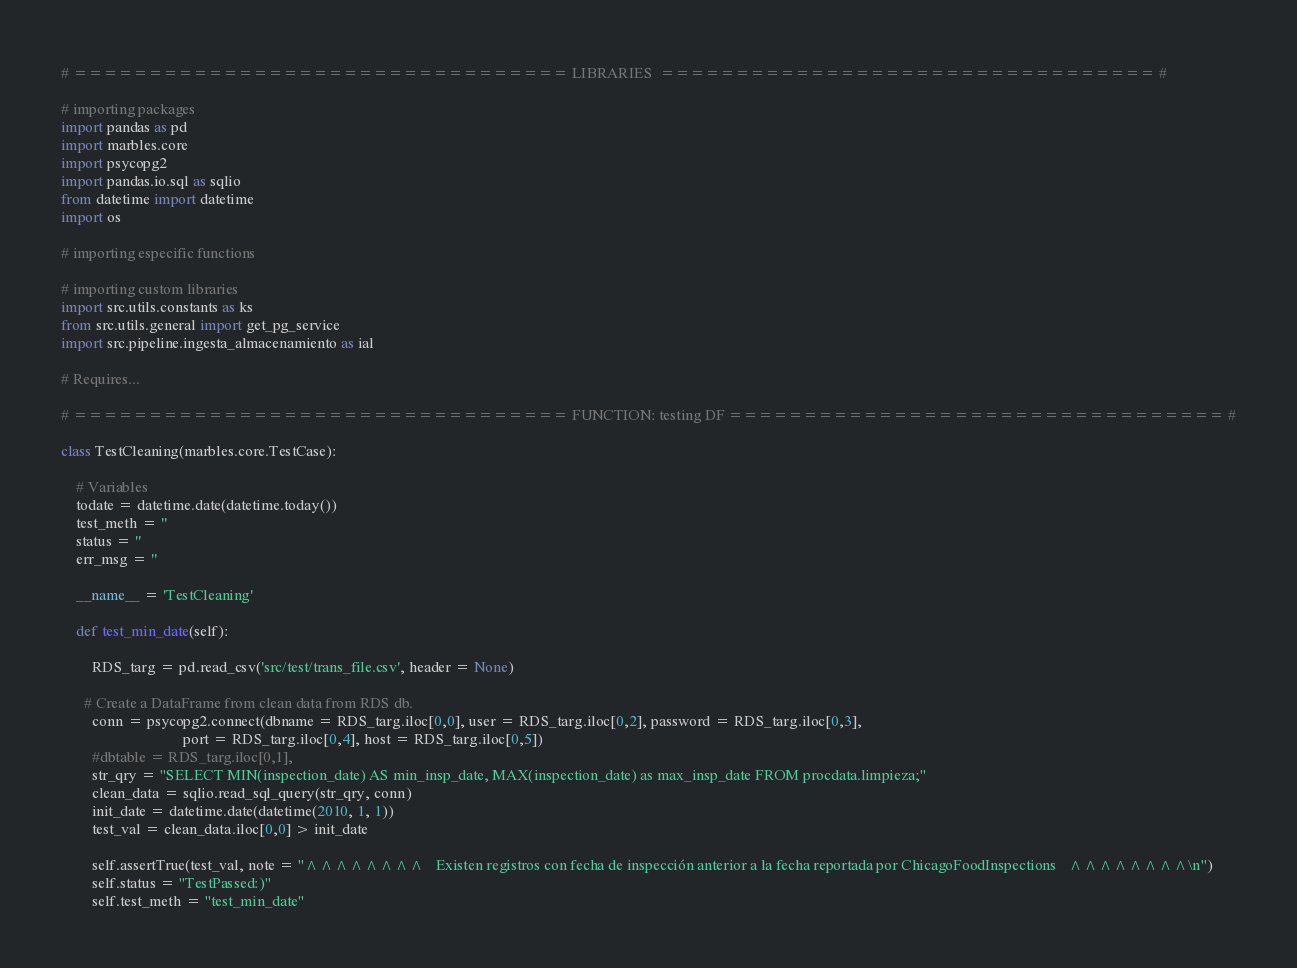Convert code to text. <code><loc_0><loc_0><loc_500><loc_500><_Python_># ================================= LIBRARIES  ================================= #

# importing packages
import pandas as pd
import marbles.core
import psycopg2
import pandas.io.sql as sqlio
from datetime import datetime
import os

# importing especific functions

# importing custom libraries
import src.utils.constants as ks
from src.utils.general import get_pg_service
import src.pipeline.ingesta_almacenamiento as ial

# Requires...

# ================================= FUNCTION: testing DF ================================= #

class TestCleaning(marbles.core.TestCase):
    
    # Variables
    todate = datetime.date(datetime.today())
    test_meth = ''
    status = ''
    err_msg = ''

    __name__ = 'TestCleaning'
    
    def test_min_date(self):

        RDS_targ = pd.read_csv('src/test/trans_file.csv', header = None)
        
      # Create a DataFrame from clean data from RDS db.
        conn = psycopg2.connect(dbname = RDS_targ.iloc[0,0], user = RDS_targ.iloc[0,2], password = RDS_targ.iloc[0,3],
                                port = RDS_targ.iloc[0,4], host = RDS_targ.iloc[0,5])
        #dbtable = RDS_targ.iloc[0,1],
        str_qry = "SELECT MIN(inspection_date) AS min_insp_date, MAX(inspection_date) as max_insp_date FROM procdata.limpieza;"
        clean_data = sqlio.read_sql_query(str_qry, conn)
        init_date = datetime.date(datetime(2010, 1, 1)) 
        test_val = clean_data.iloc[0,0] > init_date
        
        self.assertTrue(test_val, note = "^^^^^^^^   Existen registros con fecha de inspección anterior a la fecha reportada por ChicagoFoodInspections   ^^^^^^^^\n")
        self.status = "TestPassed:)"
        self.test_meth = "test_min_date"</code> 